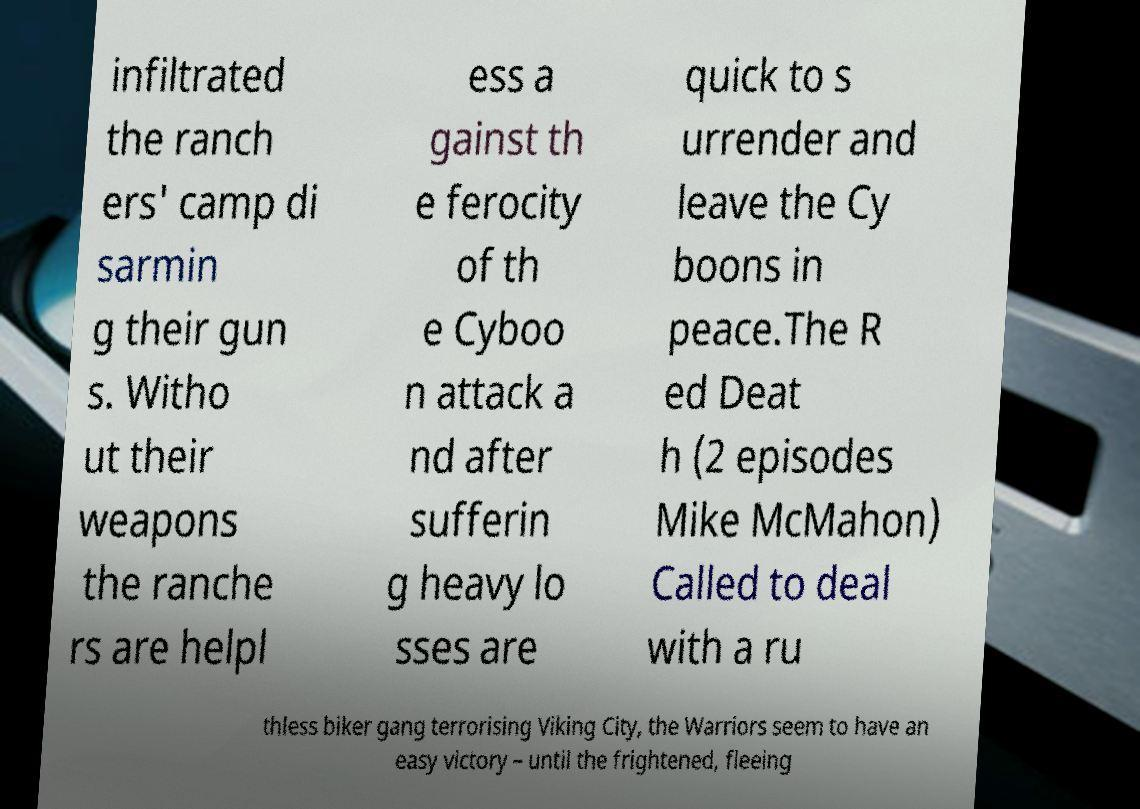Please identify and transcribe the text found in this image. infiltrated the ranch ers' camp di sarmin g their gun s. Witho ut their weapons the ranche rs are helpl ess a gainst th e ferocity of th e Cyboo n attack a nd after sufferin g heavy lo sses are quick to s urrender and leave the Cy boons in peace.The R ed Deat h (2 episodes Mike McMahon) Called to deal with a ru thless biker gang terrorising Viking City, the Warriors seem to have an easy victory – until the frightened, fleeing 